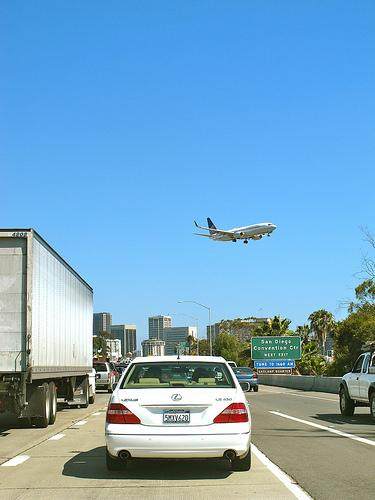Describe the most visually compelling aspect of the image. An airplane flying high in the sky on a clear blue, cloudless day, captured alongside a busy highway scene below. Highlight the components of the image that indicate the location or environment. The image features street signs for the San Diego Convention Center, a city skyline with several buildings, green palm trees, and a busy highway, suggesting an urban setting. Use the background details in the image to guess the time of day or weather. The image seems to be taken during a sunny day, given the clear blue sky, absence of clouds, and bright lighting on the cars and street signs. Provide a brief summary of the overall scene in the image. An image featuring various vehicles on the highway, including a white Lexus, trucks, and a blue car, as well as an airplane in the sky and street signs for the San Diego Convention Center. Mention the most prominent object in the image and provide details about its appearance. The central object in the image is a white Lexus with red taillights and a visible emblem, seen driving on the highway. Write a poem summarizing the key subjects of the image. San Diego, here we view. Narrate the image as if you were painting a picture using words. In a bustling cityscape, a white Lexus glides effortlessly down a lively highway, with the sun reflecting on red taillights while a plane soars gracefully above in the azure sky, palm trees waving gently in the foreground. Create a short advertisement for visiting San Diego using the elements present in the image. Experience the excitement of San Diego! Cruise down the sun-soaked highways in luxurious vehicles, explore our world-renowned convention center, and marvel at airplanes soaring through crystal-clear skies. Book your trip today! Provide a brief, yet detailed description of a specific part of the image that caught your attention. An intriguing feature of this image is the white Lexus on the highway, with the vehicle emblem prominently displayed, showcasing its luxury and smooth appearance along the busy road. Comment on how the different elements in the image make it appealing. The combination of a busy highway scene with various vehicles, street signs for the San Diego Convention Center, an airplane in the clear blue sky, and lush green palm trees make this image engaging and dynamic. 